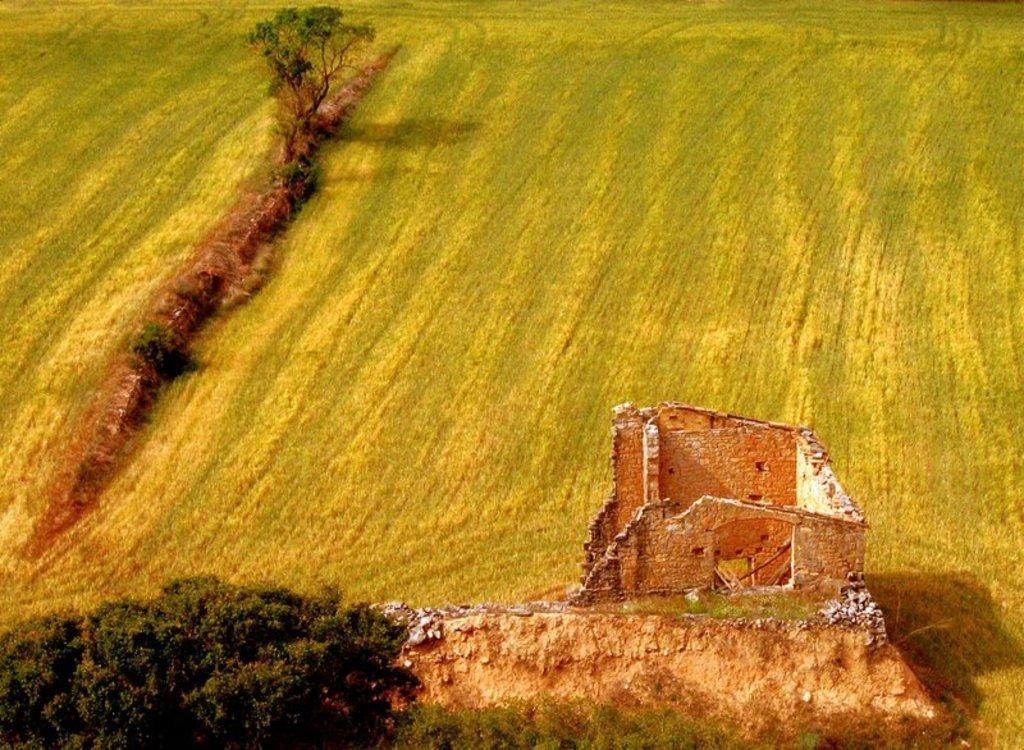What is the condition of the wall in the image? The wall in the image is broken. What can be seen around the area of the image? There is greenery around the area of the image. How many tomatoes are in the pocket of the person in the image? There is no person or pocket visible in the image, and therefore no tomatoes can be found. 